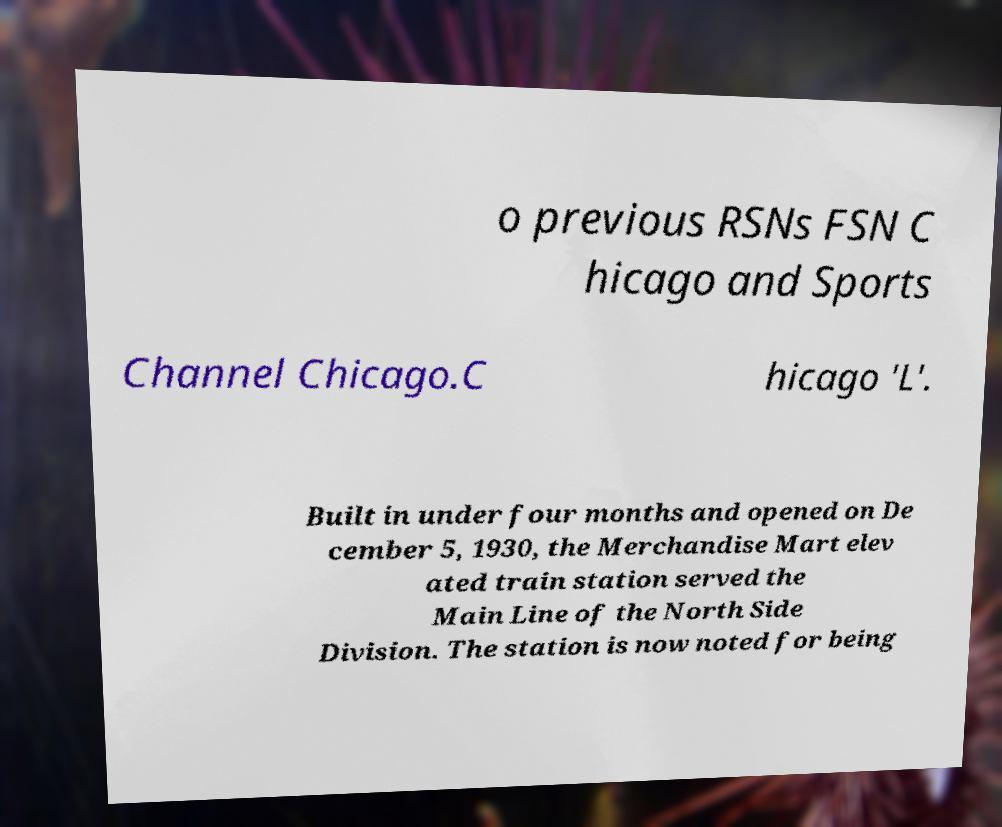Could you assist in decoding the text presented in this image and type it out clearly? o previous RSNs FSN C hicago and Sports Channel Chicago.C hicago 'L'. Built in under four months and opened on De cember 5, 1930, the Merchandise Mart elev ated train station served the Main Line of the North Side Division. The station is now noted for being 